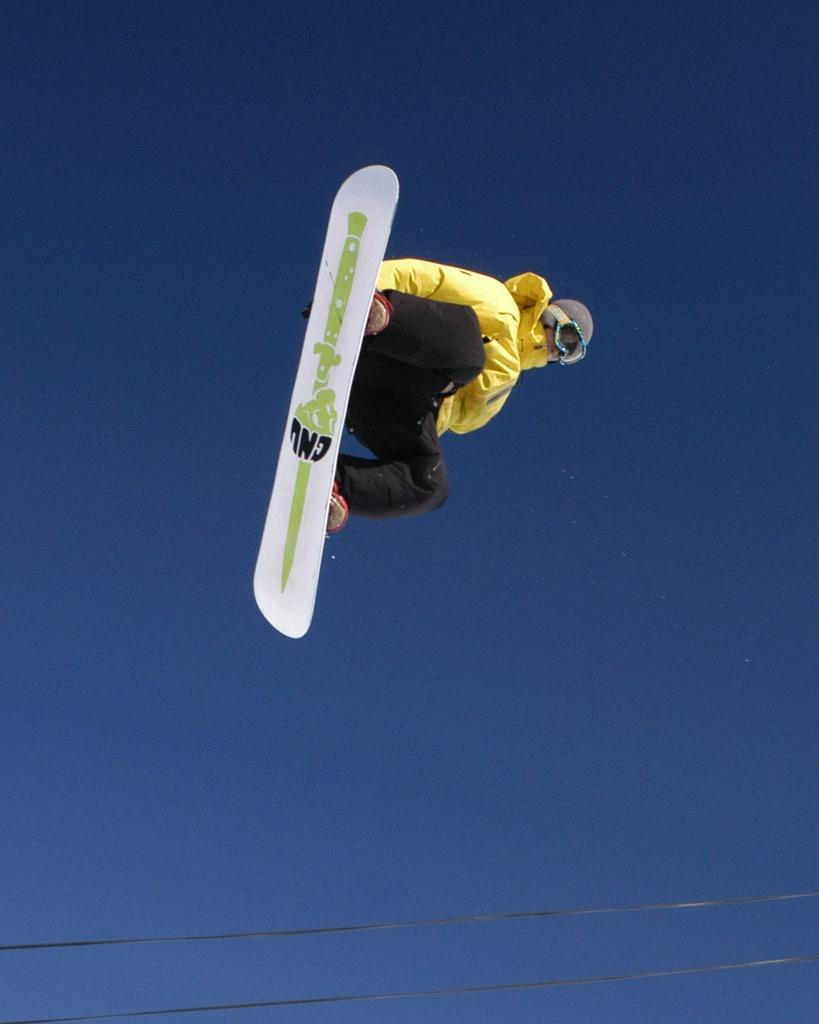What is the person in the image doing? The person is using a snowboard. How is the person positioned in relation to the ground? The person is in the air. What is the color of the sky in the image? The sky is blue in color. What type of jelly can be seen on the person's snowboard in the image? There is no jelly present on the person's snowboard in the image. 